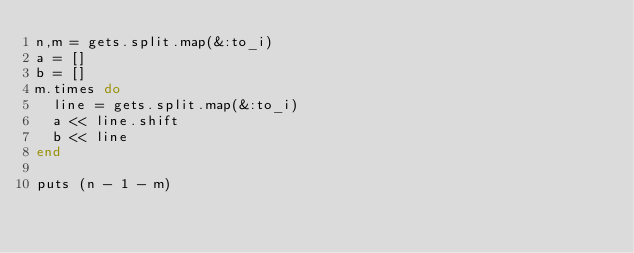<code> <loc_0><loc_0><loc_500><loc_500><_Ruby_>n,m = gets.split.map(&:to_i)
a = []
b = []
m.times do
  line = gets.split.map(&:to_i)
  a << line.shift
  b << line
end

puts (n - 1 - m)</code> 